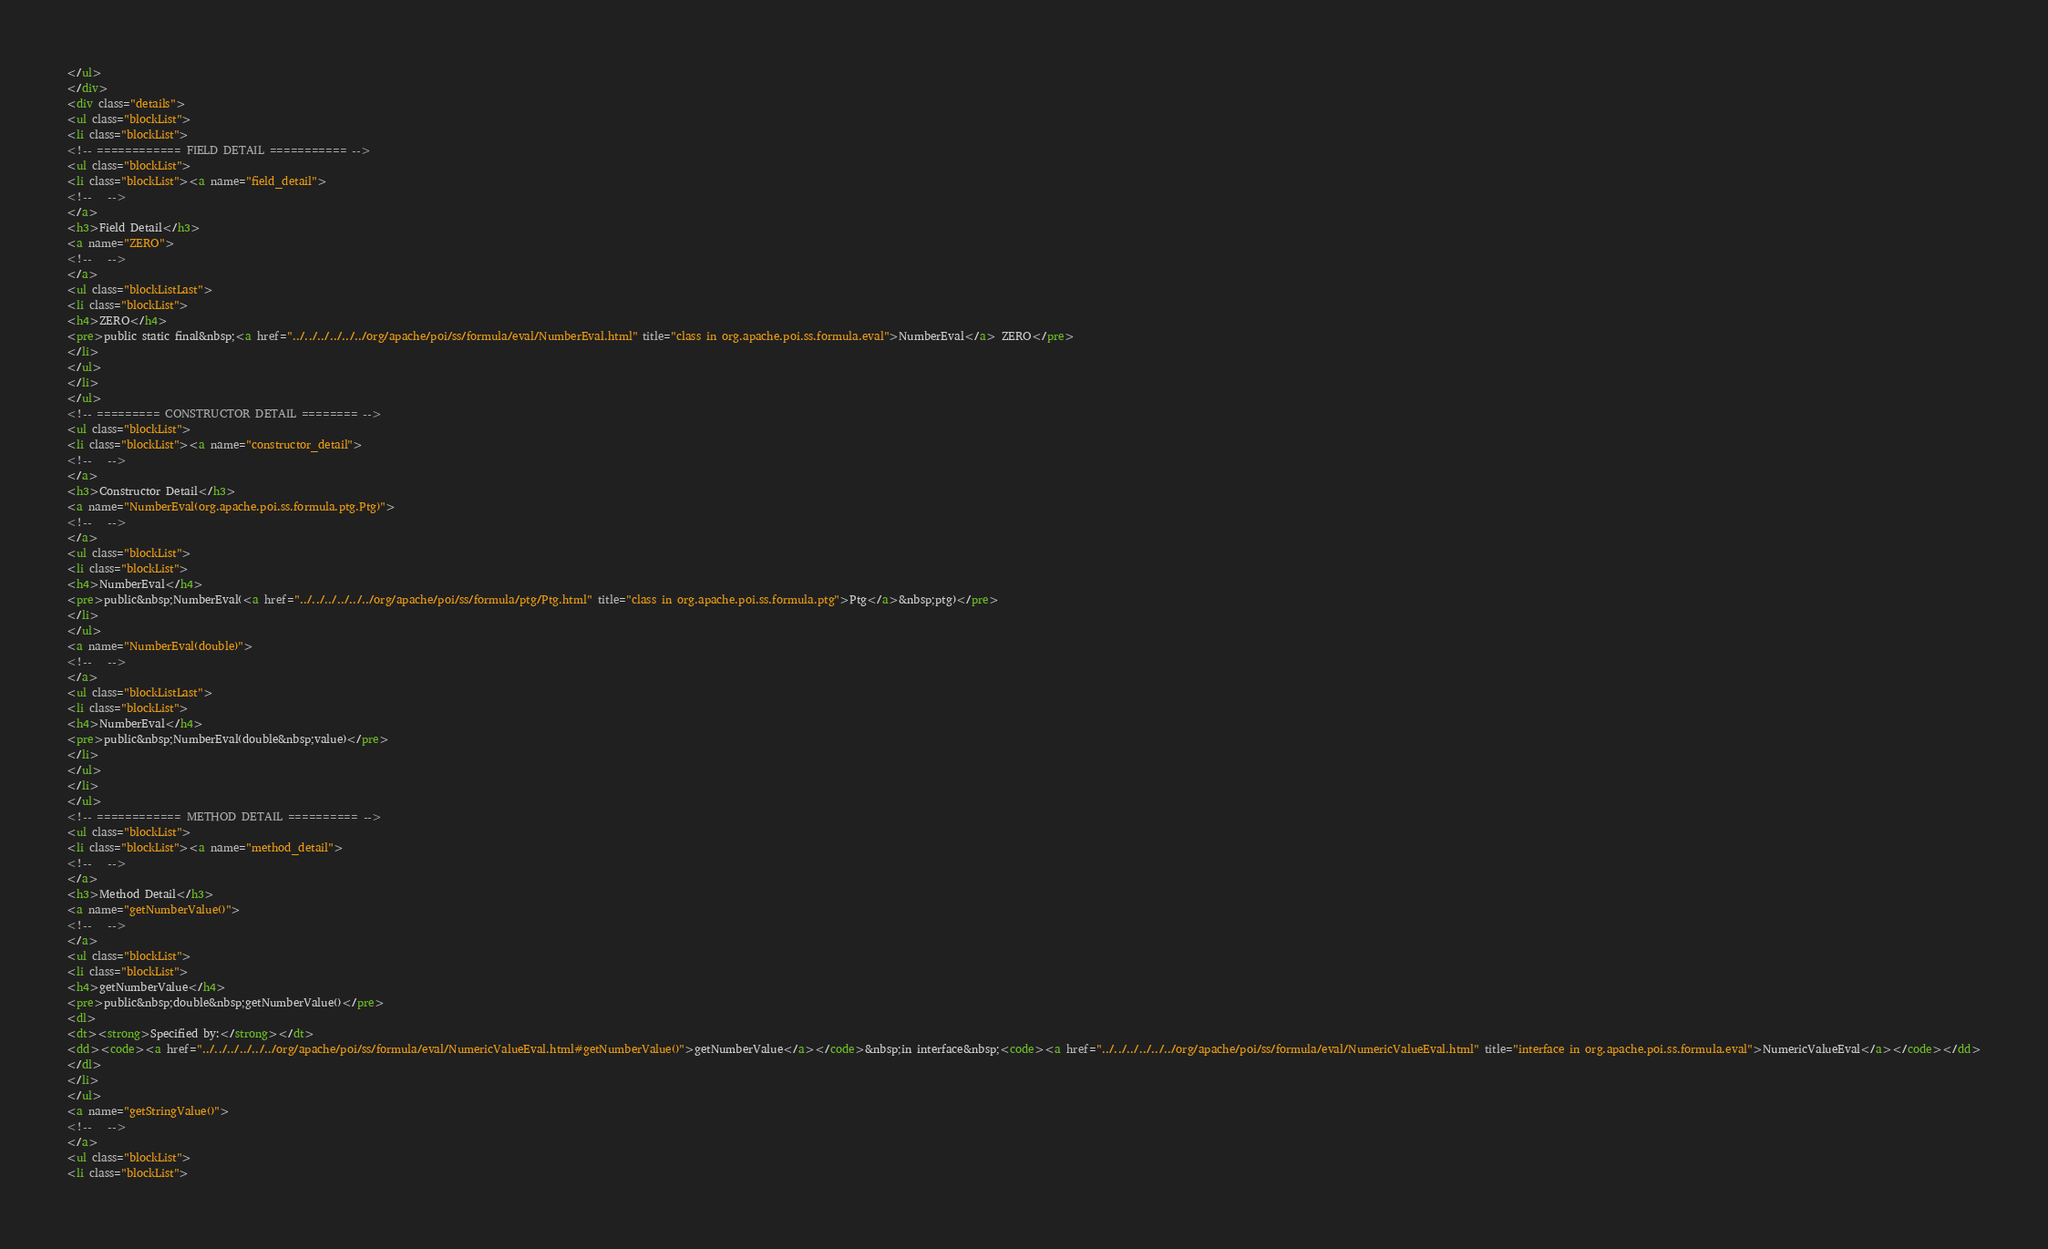<code> <loc_0><loc_0><loc_500><loc_500><_HTML_></ul>
</div>
<div class="details">
<ul class="blockList">
<li class="blockList">
<!-- ============ FIELD DETAIL =========== -->
<ul class="blockList">
<li class="blockList"><a name="field_detail">
<!--   -->
</a>
<h3>Field Detail</h3>
<a name="ZERO">
<!--   -->
</a>
<ul class="blockListLast">
<li class="blockList">
<h4>ZERO</h4>
<pre>public static final&nbsp;<a href="../../../../../../org/apache/poi/ss/formula/eval/NumberEval.html" title="class in org.apache.poi.ss.formula.eval">NumberEval</a> ZERO</pre>
</li>
</ul>
</li>
</ul>
<!-- ========= CONSTRUCTOR DETAIL ======== -->
<ul class="blockList">
<li class="blockList"><a name="constructor_detail">
<!--   -->
</a>
<h3>Constructor Detail</h3>
<a name="NumberEval(org.apache.poi.ss.formula.ptg.Ptg)">
<!--   -->
</a>
<ul class="blockList">
<li class="blockList">
<h4>NumberEval</h4>
<pre>public&nbsp;NumberEval(<a href="../../../../../../org/apache/poi/ss/formula/ptg/Ptg.html" title="class in org.apache.poi.ss.formula.ptg">Ptg</a>&nbsp;ptg)</pre>
</li>
</ul>
<a name="NumberEval(double)">
<!--   -->
</a>
<ul class="blockListLast">
<li class="blockList">
<h4>NumberEval</h4>
<pre>public&nbsp;NumberEval(double&nbsp;value)</pre>
</li>
</ul>
</li>
</ul>
<!-- ============ METHOD DETAIL ========== -->
<ul class="blockList">
<li class="blockList"><a name="method_detail">
<!--   -->
</a>
<h3>Method Detail</h3>
<a name="getNumberValue()">
<!--   -->
</a>
<ul class="blockList">
<li class="blockList">
<h4>getNumberValue</h4>
<pre>public&nbsp;double&nbsp;getNumberValue()</pre>
<dl>
<dt><strong>Specified by:</strong></dt>
<dd><code><a href="../../../../../../org/apache/poi/ss/formula/eval/NumericValueEval.html#getNumberValue()">getNumberValue</a></code>&nbsp;in interface&nbsp;<code><a href="../../../../../../org/apache/poi/ss/formula/eval/NumericValueEval.html" title="interface in org.apache.poi.ss.formula.eval">NumericValueEval</a></code></dd>
</dl>
</li>
</ul>
<a name="getStringValue()">
<!--   -->
</a>
<ul class="blockList">
<li class="blockList"></code> 